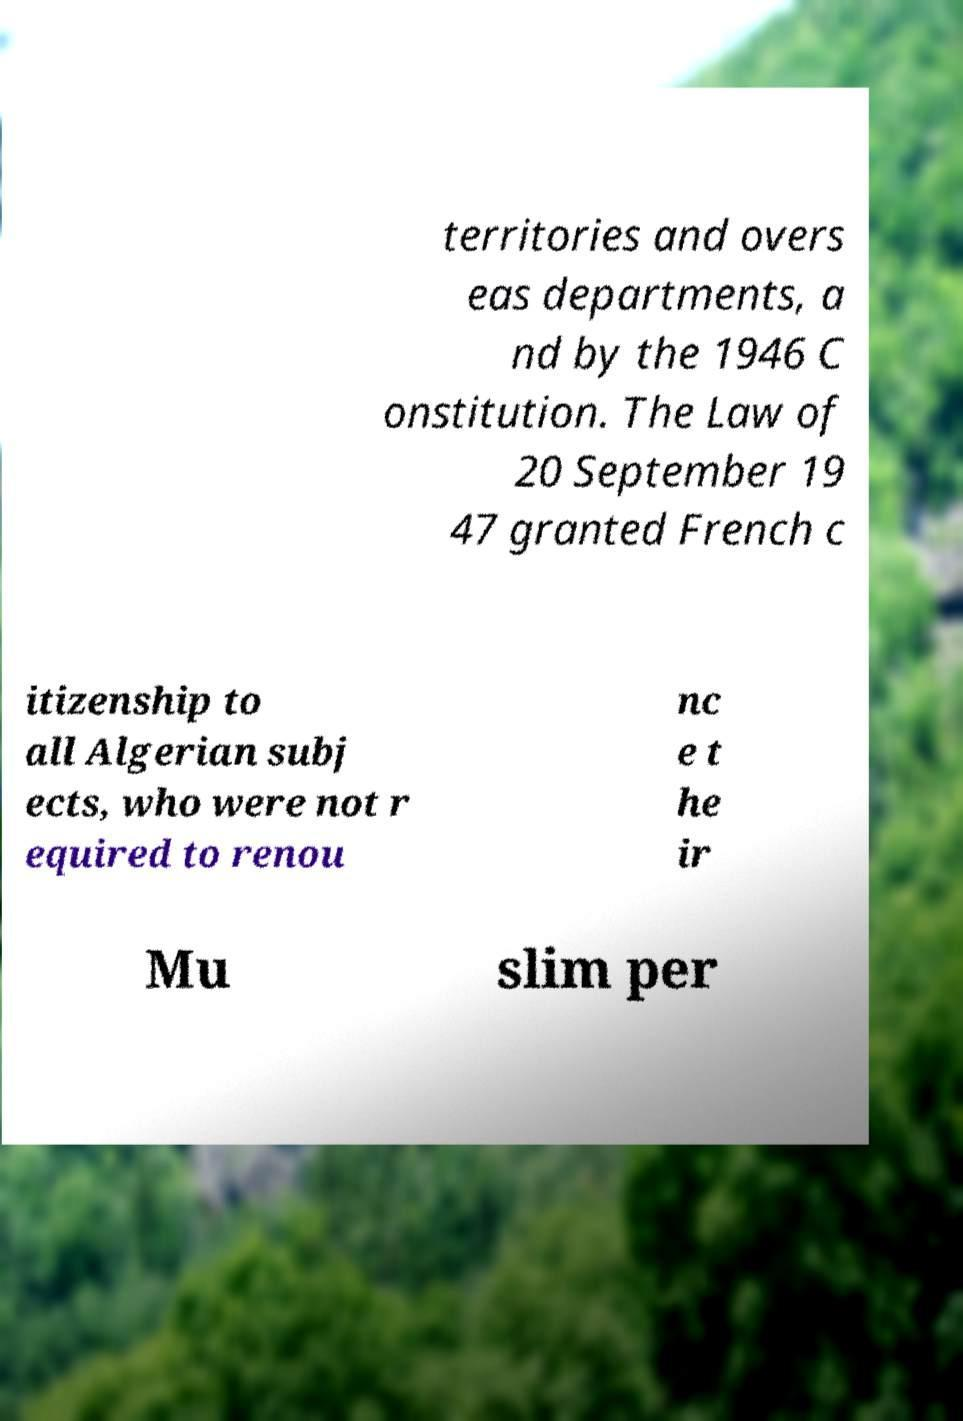Can you read and provide the text displayed in the image?This photo seems to have some interesting text. Can you extract and type it out for me? territories and overs eas departments, a nd by the 1946 C onstitution. The Law of 20 September 19 47 granted French c itizenship to all Algerian subj ects, who were not r equired to renou nc e t he ir Mu slim per 